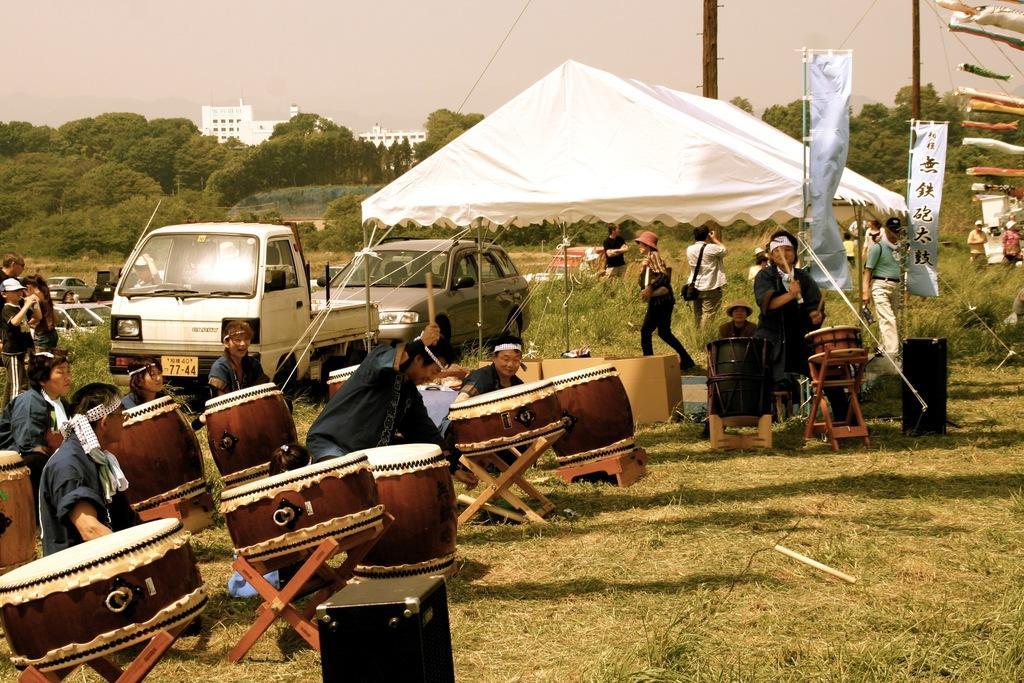Describe this image in one or two sentences. At the top we can sky. These are buildings and trees. Here we can see a white colour tent. These are flags. We can see persons standing, walking , sitting. Here we can see cars. These are speakers. This is a green grass. 